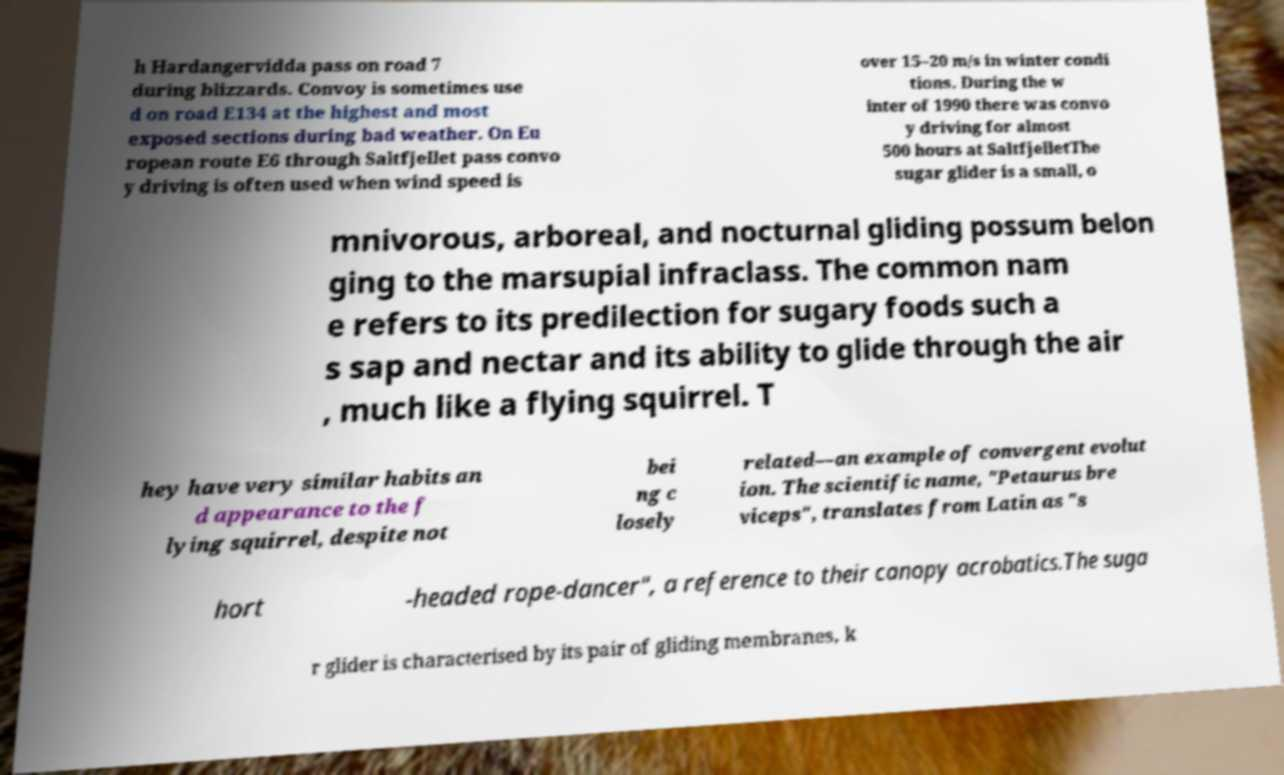Please read and relay the text visible in this image. What does it say? h Hardangervidda pass on road 7 during blizzards. Convoy is sometimes use d on road E134 at the highest and most exposed sections during bad weather. On Eu ropean route E6 through Saltfjellet pass convo y driving is often used when wind speed is over 15–20 m/s in winter condi tions. During the w inter of 1990 there was convo y driving for almost 500 hours at SaltfjelletThe sugar glider is a small, o mnivorous, arboreal, and nocturnal gliding possum belon ging to the marsupial infraclass. The common nam e refers to its predilection for sugary foods such a s sap and nectar and its ability to glide through the air , much like a flying squirrel. T hey have very similar habits an d appearance to the f lying squirrel, despite not bei ng c losely related—an example of convergent evolut ion. The scientific name, "Petaurus bre viceps", translates from Latin as "s hort -headed rope-dancer", a reference to their canopy acrobatics.The suga r glider is characterised by its pair of gliding membranes, k 